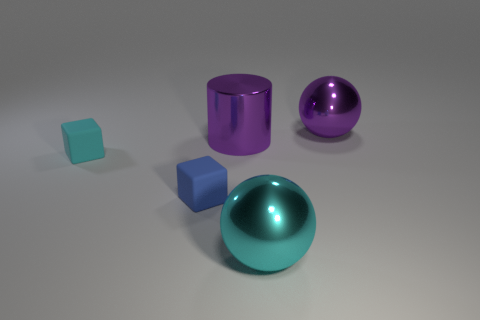Can you describe the lighting in the scene? The lighting in the scene is soft and diffused, suggesting an ambient light source. There is a gentle shadow cast by each object, indicating the light may be coming from the top left side of the frame. The reflections on the objects suggest that the light source is not overly harsh or direct. 